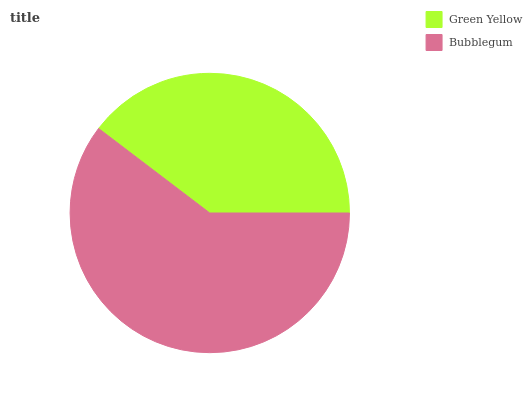Is Green Yellow the minimum?
Answer yes or no. Yes. Is Bubblegum the maximum?
Answer yes or no. Yes. Is Bubblegum the minimum?
Answer yes or no. No. Is Bubblegum greater than Green Yellow?
Answer yes or no. Yes. Is Green Yellow less than Bubblegum?
Answer yes or no. Yes. Is Green Yellow greater than Bubblegum?
Answer yes or no. No. Is Bubblegum less than Green Yellow?
Answer yes or no. No. Is Bubblegum the high median?
Answer yes or no. Yes. Is Green Yellow the low median?
Answer yes or no. Yes. Is Green Yellow the high median?
Answer yes or no. No. Is Bubblegum the low median?
Answer yes or no. No. 